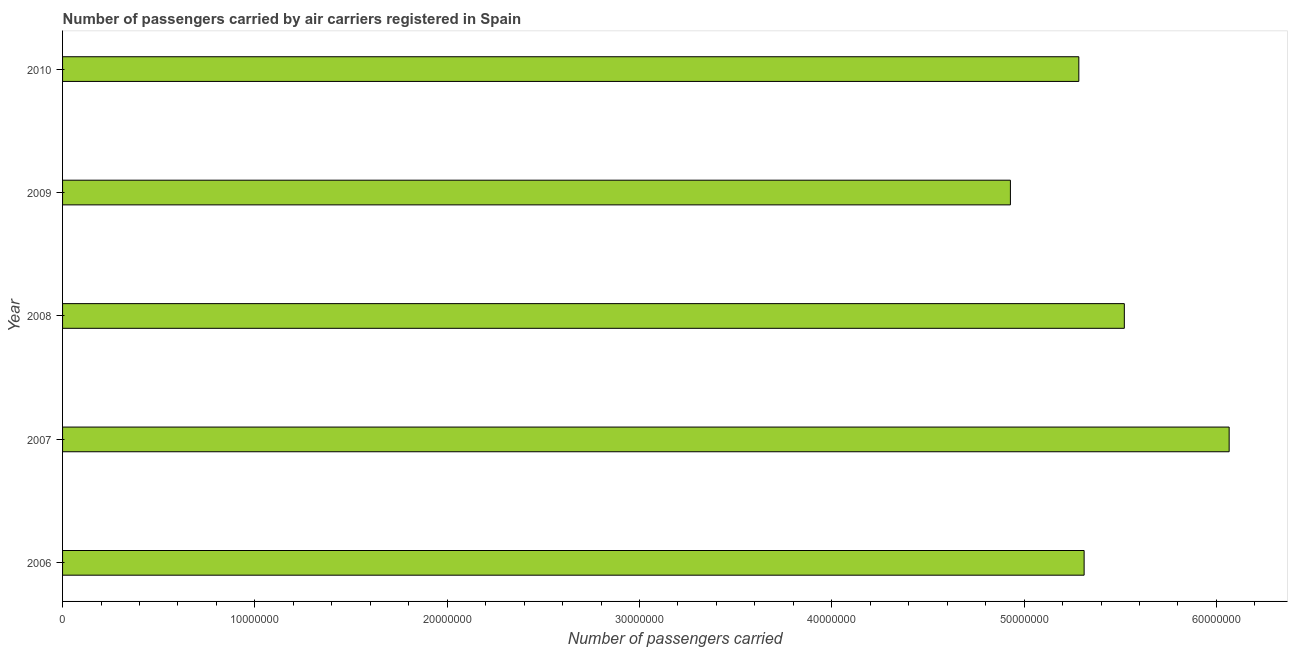Does the graph contain any zero values?
Give a very brief answer. No. What is the title of the graph?
Your response must be concise. Number of passengers carried by air carriers registered in Spain. What is the label or title of the X-axis?
Your answer should be compact. Number of passengers carried. What is the label or title of the Y-axis?
Provide a succinct answer. Year. What is the number of passengers carried in 2010?
Provide a short and direct response. 5.28e+07. Across all years, what is the maximum number of passengers carried?
Make the answer very short. 6.07e+07. Across all years, what is the minimum number of passengers carried?
Your answer should be very brief. 4.93e+07. In which year was the number of passengers carried maximum?
Provide a short and direct response. 2007. What is the sum of the number of passengers carried?
Your answer should be compact. 2.71e+08. What is the difference between the number of passengers carried in 2007 and 2010?
Your answer should be very brief. 7.82e+06. What is the average number of passengers carried per year?
Give a very brief answer. 5.42e+07. What is the median number of passengers carried?
Ensure brevity in your answer.  5.31e+07. What is the ratio of the number of passengers carried in 2009 to that in 2010?
Offer a terse response. 0.93. Is the difference between the number of passengers carried in 2007 and 2010 greater than the difference between any two years?
Your response must be concise. No. What is the difference between the highest and the second highest number of passengers carried?
Your response must be concise. 5.45e+06. Is the sum of the number of passengers carried in 2007 and 2010 greater than the maximum number of passengers carried across all years?
Your answer should be very brief. Yes. What is the difference between the highest and the lowest number of passengers carried?
Your answer should be very brief. 1.14e+07. Are all the bars in the graph horizontal?
Keep it short and to the point. Yes. How many years are there in the graph?
Your answer should be very brief. 5. What is the difference between two consecutive major ticks on the X-axis?
Offer a very short reply. 1.00e+07. What is the Number of passengers carried of 2006?
Keep it short and to the point. 5.31e+07. What is the Number of passengers carried in 2007?
Offer a very short reply. 6.07e+07. What is the Number of passengers carried in 2008?
Your response must be concise. 5.52e+07. What is the Number of passengers carried in 2009?
Your answer should be very brief. 4.93e+07. What is the Number of passengers carried of 2010?
Give a very brief answer. 5.28e+07. What is the difference between the Number of passengers carried in 2006 and 2007?
Your response must be concise. -7.54e+06. What is the difference between the Number of passengers carried in 2006 and 2008?
Ensure brevity in your answer.  -2.09e+06. What is the difference between the Number of passengers carried in 2006 and 2009?
Your answer should be very brief. 3.83e+06. What is the difference between the Number of passengers carried in 2006 and 2010?
Your answer should be compact. 2.75e+05. What is the difference between the Number of passengers carried in 2007 and 2008?
Give a very brief answer. 5.45e+06. What is the difference between the Number of passengers carried in 2007 and 2009?
Give a very brief answer. 1.14e+07. What is the difference between the Number of passengers carried in 2007 and 2010?
Offer a terse response. 7.82e+06. What is the difference between the Number of passengers carried in 2008 and 2009?
Offer a terse response. 5.92e+06. What is the difference between the Number of passengers carried in 2008 and 2010?
Your answer should be very brief. 2.37e+06. What is the difference between the Number of passengers carried in 2009 and 2010?
Give a very brief answer. -3.56e+06. What is the ratio of the Number of passengers carried in 2006 to that in 2007?
Offer a terse response. 0.88. What is the ratio of the Number of passengers carried in 2006 to that in 2009?
Provide a succinct answer. 1.08. What is the ratio of the Number of passengers carried in 2007 to that in 2008?
Give a very brief answer. 1.1. What is the ratio of the Number of passengers carried in 2007 to that in 2009?
Offer a terse response. 1.23. What is the ratio of the Number of passengers carried in 2007 to that in 2010?
Your answer should be very brief. 1.15. What is the ratio of the Number of passengers carried in 2008 to that in 2009?
Your answer should be very brief. 1.12. What is the ratio of the Number of passengers carried in 2008 to that in 2010?
Give a very brief answer. 1.04. What is the ratio of the Number of passengers carried in 2009 to that in 2010?
Provide a short and direct response. 0.93. 